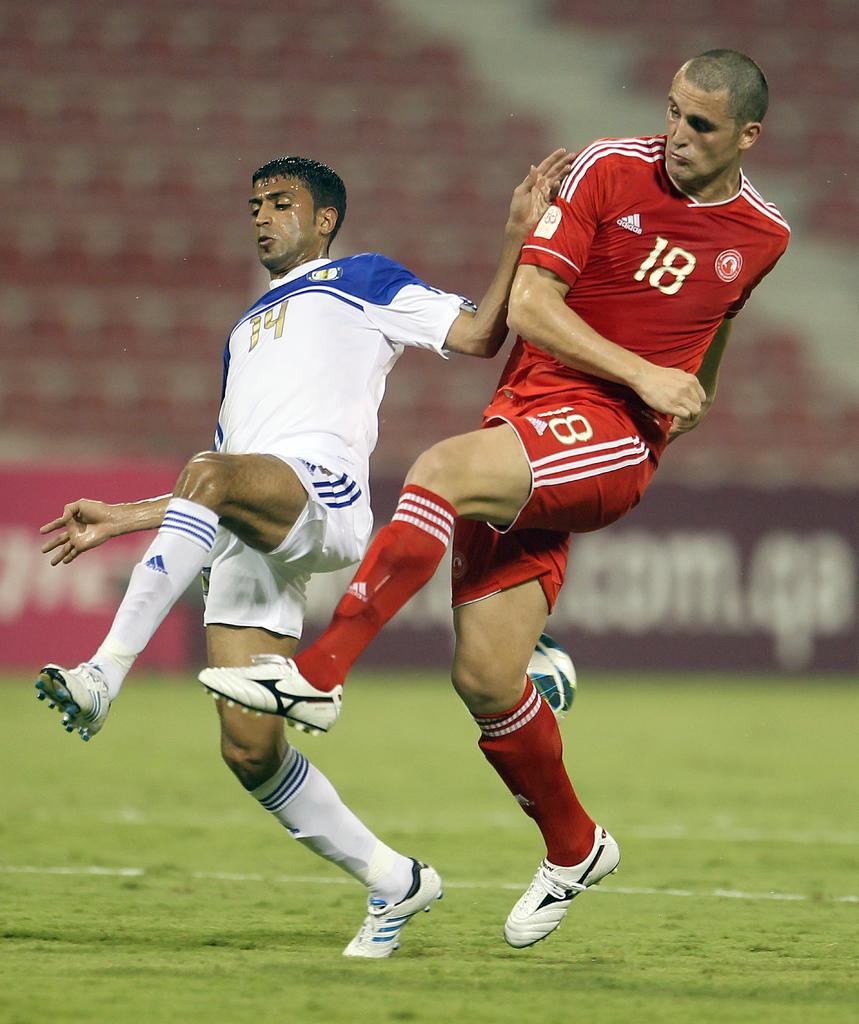<image>
Give a short and clear explanation of the subsequent image. a couple soccer players playing including one with the number 18 